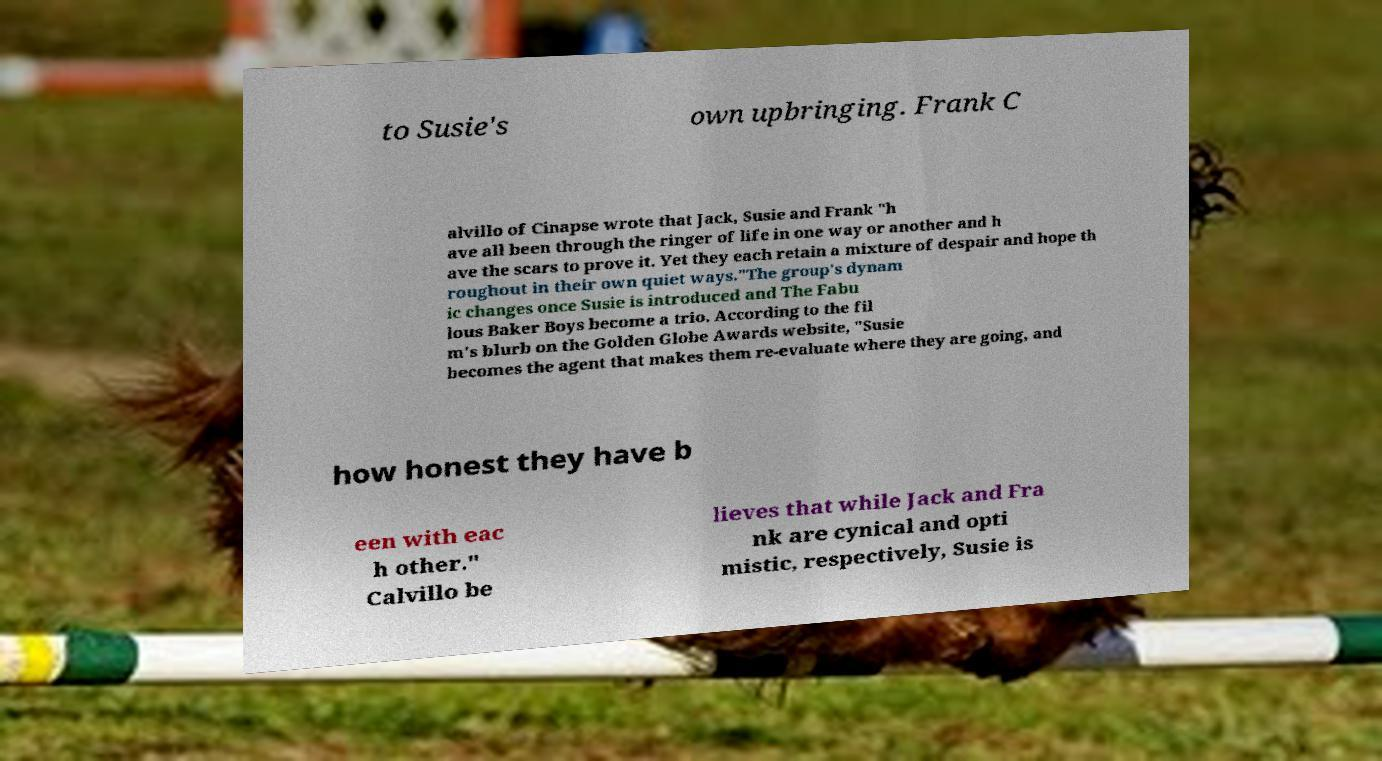There's text embedded in this image that I need extracted. Can you transcribe it verbatim? to Susie's own upbringing. Frank C alvillo of Cinapse wrote that Jack, Susie and Frank "h ave all been through the ringer of life in one way or another and h ave the scars to prove it. Yet they each retain a mixture of despair and hope th roughout in their own quiet ways."The group's dynam ic changes once Susie is introduced and The Fabu lous Baker Boys become a trio. According to the fil m's blurb on the Golden Globe Awards website, "Susie becomes the agent that makes them re-evaluate where they are going, and how honest they have b een with eac h other." Calvillo be lieves that while Jack and Fra nk are cynical and opti mistic, respectively, Susie is 